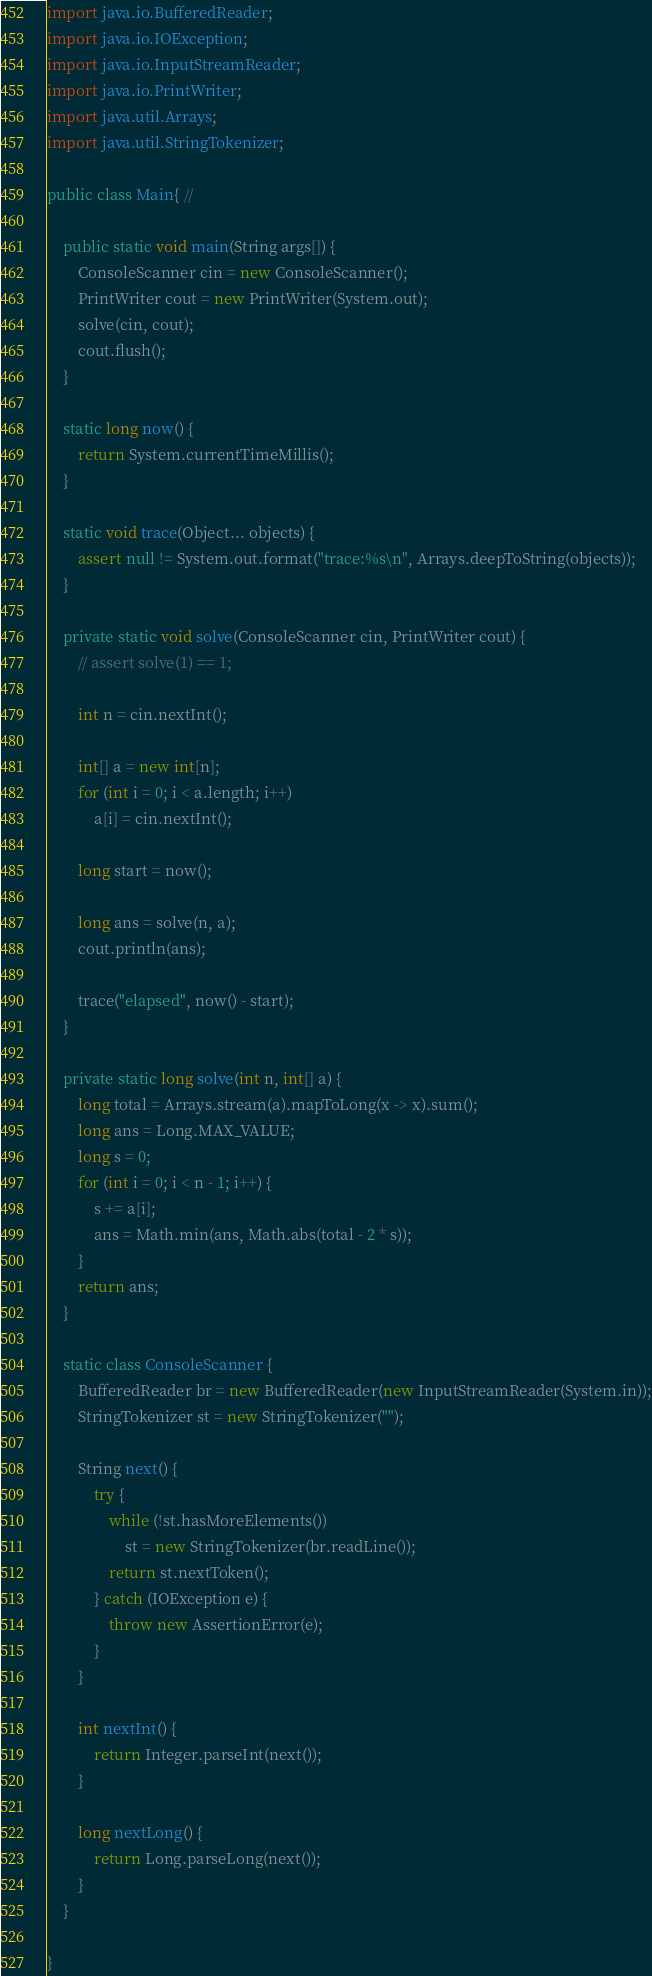<code> <loc_0><loc_0><loc_500><loc_500><_Java_>import java.io.BufferedReader;
import java.io.IOException;
import java.io.InputStreamReader;
import java.io.PrintWriter;
import java.util.Arrays;
import java.util.StringTokenizer;

public class Main{ // 

	public static void main(String args[]) {
		ConsoleScanner cin = new ConsoleScanner();
		PrintWriter cout = new PrintWriter(System.out);
		solve(cin, cout);
		cout.flush();
	}

	static long now() {
		return System.currentTimeMillis();
	}

	static void trace(Object... objects) {
		assert null != System.out.format("trace:%s\n", Arrays.deepToString(objects));
	}

	private static void solve(ConsoleScanner cin, PrintWriter cout) {
		// assert solve(1) == 1;

		int n = cin.nextInt();

		int[] a = new int[n];
		for (int i = 0; i < a.length; i++)
			a[i] = cin.nextInt();

		long start = now();

		long ans = solve(n, a);
		cout.println(ans);

		trace("elapsed", now() - start);
	}

	private static long solve(int n, int[] a) {
		long total = Arrays.stream(a).mapToLong(x -> x).sum();
		long ans = Long.MAX_VALUE;
		long s = 0;
		for (int i = 0; i < n - 1; i++) {
			s += a[i];
			ans = Math.min(ans, Math.abs(total - 2 * s));
		}
		return ans;
	}

	static class ConsoleScanner {
		BufferedReader br = new BufferedReader(new InputStreamReader(System.in));
		StringTokenizer st = new StringTokenizer("");

		String next() {
			try {
				while (!st.hasMoreElements())
					st = new StringTokenizer(br.readLine());
				return st.nextToken();
			} catch (IOException e) {
				throw new AssertionError(e);
			}
		}

		int nextInt() {
			return Integer.parseInt(next());
		}

		long nextLong() {
			return Long.parseLong(next());
		}
	}

}
</code> 